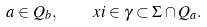<formula> <loc_0><loc_0><loc_500><loc_500>a \in Q _ { b } , \quad x i \in \gamma \subset \Sigma \cap Q _ { a } .</formula> 